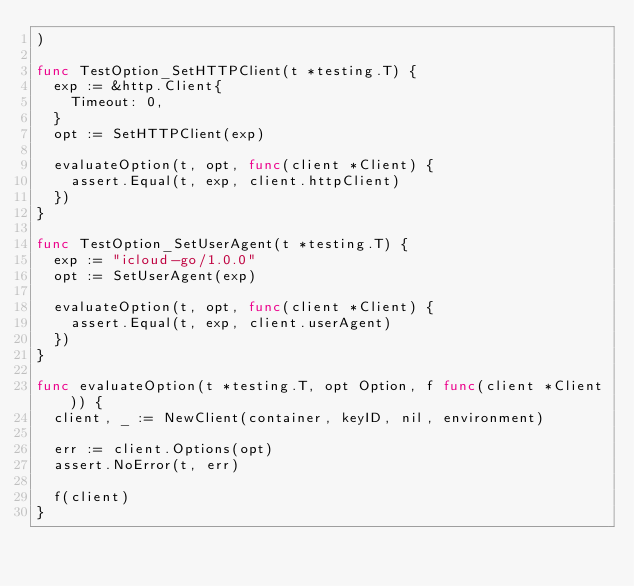Convert code to text. <code><loc_0><loc_0><loc_500><loc_500><_Go_>)

func TestOption_SetHTTPClient(t *testing.T) {
	exp := &http.Client{
		Timeout: 0,
	}
	opt := SetHTTPClient(exp)

	evaluateOption(t, opt, func(client *Client) {
		assert.Equal(t, exp, client.httpClient)
	})
}

func TestOption_SetUserAgent(t *testing.T) {
	exp := "icloud-go/1.0.0"
	opt := SetUserAgent(exp)

	evaluateOption(t, opt, func(client *Client) {
		assert.Equal(t, exp, client.userAgent)
	})
}

func evaluateOption(t *testing.T, opt Option, f func(client *Client)) {
	client, _ := NewClient(container, keyID, nil, environment)

	err := client.Options(opt)
	assert.NoError(t, err)

	f(client)
}
</code> 